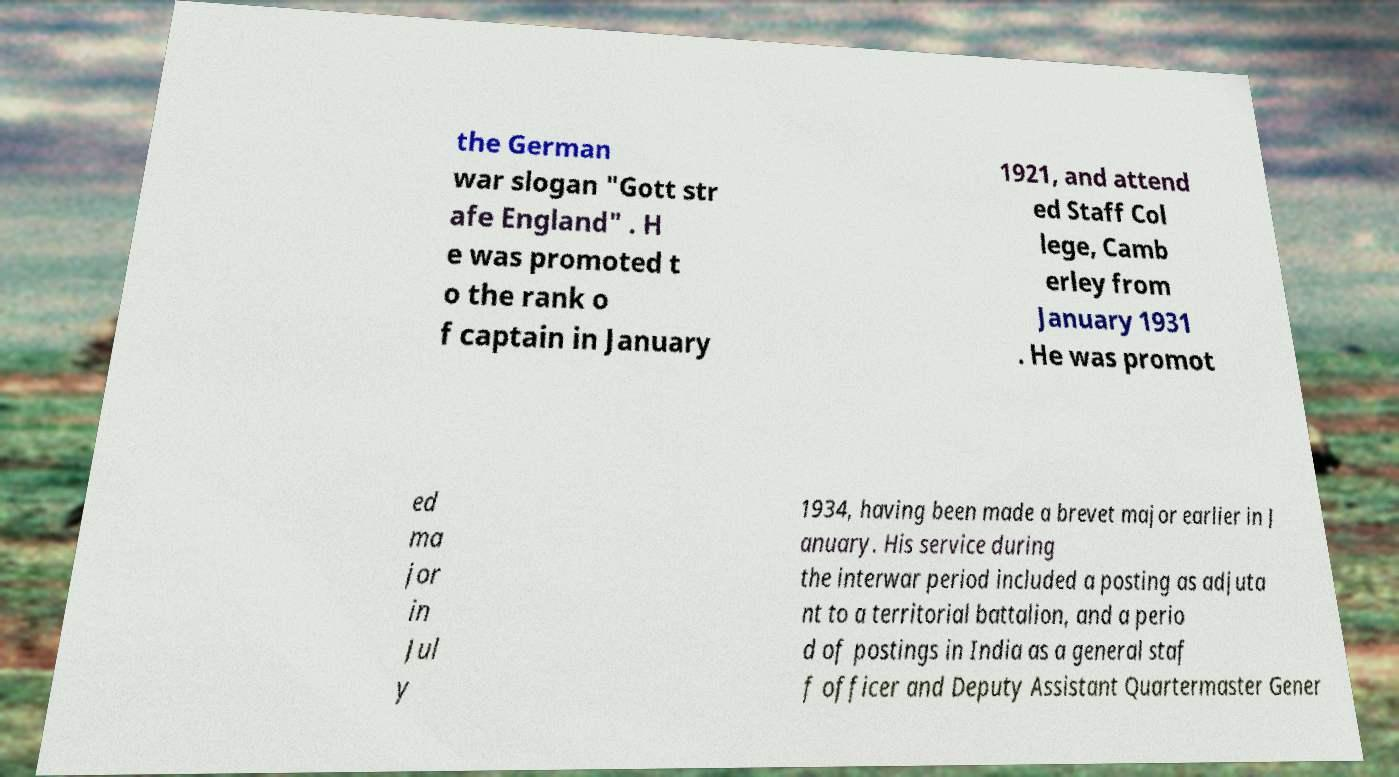Can you read and provide the text displayed in the image?This photo seems to have some interesting text. Can you extract and type it out for me? the German war slogan "Gott str afe England" . H e was promoted t o the rank o f captain in January 1921, and attend ed Staff Col lege, Camb erley from January 1931 . He was promot ed ma jor in Jul y 1934, having been made a brevet major earlier in J anuary. His service during the interwar period included a posting as adjuta nt to a territorial battalion, and a perio d of postings in India as a general staf f officer and Deputy Assistant Quartermaster Gener 